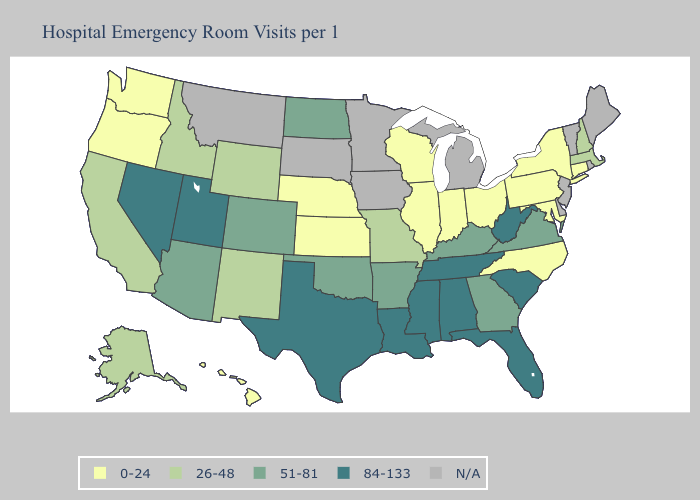Name the states that have a value in the range 51-81?
Short answer required. Arizona, Arkansas, Colorado, Georgia, Kentucky, North Dakota, Oklahoma, Virginia. Does Wyoming have the lowest value in the West?
Write a very short answer. No. How many symbols are there in the legend?
Quick response, please. 5. What is the value of West Virginia?
Write a very short answer. 84-133. What is the highest value in the USA?
Concise answer only. 84-133. How many symbols are there in the legend?
Short answer required. 5. Which states have the highest value in the USA?
Answer briefly. Alabama, Florida, Louisiana, Mississippi, Nevada, South Carolina, Tennessee, Texas, Utah, West Virginia. Name the states that have a value in the range 26-48?
Short answer required. Alaska, California, Idaho, Massachusetts, Missouri, New Hampshire, New Mexico, Wyoming. Does Missouri have the lowest value in the USA?
Concise answer only. No. What is the value of North Carolina?
Concise answer only. 0-24. 